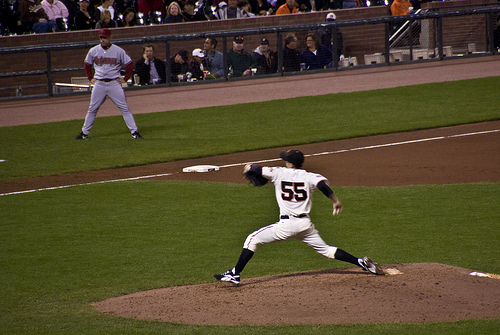What is the player in the background doing? The player in the background appears to be waiting, possibly observing the pitch or preparing for a play. 